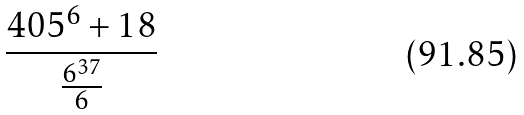Convert formula to latex. <formula><loc_0><loc_0><loc_500><loc_500>\frac { 4 0 5 ^ { 6 } + 1 8 } { \frac { 6 ^ { 3 7 } } { 6 } }</formula> 